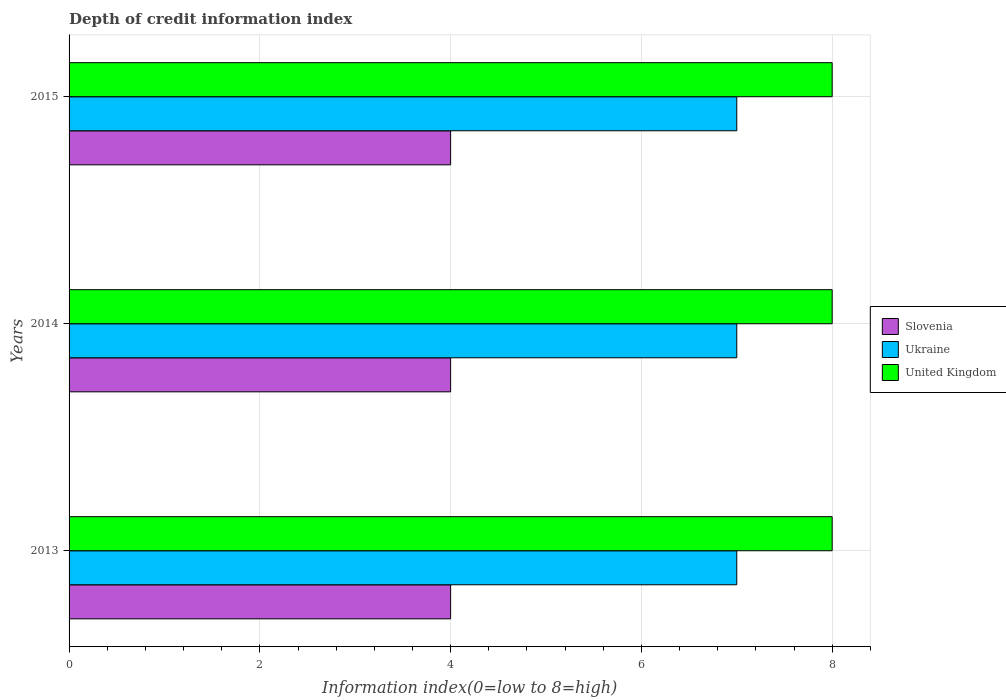How many groups of bars are there?
Provide a succinct answer. 3. Are the number of bars on each tick of the Y-axis equal?
Your answer should be compact. Yes. How many bars are there on the 2nd tick from the bottom?
Offer a terse response. 3. What is the label of the 2nd group of bars from the top?
Your response must be concise. 2014. In how many cases, is the number of bars for a given year not equal to the number of legend labels?
Your response must be concise. 0. What is the information index in Ukraine in 2014?
Your response must be concise. 7. Across all years, what is the maximum information index in Slovenia?
Your answer should be very brief. 4. Across all years, what is the minimum information index in Slovenia?
Provide a succinct answer. 4. What is the total information index in Ukraine in the graph?
Make the answer very short. 21. What is the difference between the information index in United Kingdom in 2013 and that in 2014?
Offer a very short reply. 0. What is the difference between the information index in United Kingdom in 2014 and the information index in Slovenia in 2015?
Keep it short and to the point. 4. What is the average information index in Slovenia per year?
Make the answer very short. 4. In the year 2015, what is the difference between the information index in Ukraine and information index in Slovenia?
Offer a very short reply. 3. What is the ratio of the information index in Slovenia in 2013 to that in 2014?
Your answer should be very brief. 1. Is the difference between the information index in Ukraine in 2013 and 2014 greater than the difference between the information index in Slovenia in 2013 and 2014?
Offer a terse response. No. What is the difference between the highest and the second highest information index in Slovenia?
Your response must be concise. 0. What is the difference between the highest and the lowest information index in United Kingdom?
Your response must be concise. 0. In how many years, is the information index in Ukraine greater than the average information index in Ukraine taken over all years?
Offer a terse response. 0. What does the 2nd bar from the top in 2013 represents?
Provide a succinct answer. Ukraine. What does the 1st bar from the bottom in 2013 represents?
Provide a succinct answer. Slovenia. How many bars are there?
Provide a short and direct response. 9. How many years are there in the graph?
Provide a succinct answer. 3. Are the values on the major ticks of X-axis written in scientific E-notation?
Offer a terse response. No. Where does the legend appear in the graph?
Offer a terse response. Center right. What is the title of the graph?
Your response must be concise. Depth of credit information index. What is the label or title of the X-axis?
Your answer should be very brief. Information index(0=low to 8=high). What is the label or title of the Y-axis?
Offer a very short reply. Years. What is the Information index(0=low to 8=high) in Slovenia in 2013?
Keep it short and to the point. 4. What is the Information index(0=low to 8=high) of Ukraine in 2013?
Provide a succinct answer. 7. What is the Information index(0=low to 8=high) in Slovenia in 2015?
Give a very brief answer. 4. What is the Information index(0=low to 8=high) of United Kingdom in 2015?
Give a very brief answer. 8. Across all years, what is the maximum Information index(0=low to 8=high) of Slovenia?
Offer a very short reply. 4. Across all years, what is the minimum Information index(0=low to 8=high) of Slovenia?
Make the answer very short. 4. Across all years, what is the minimum Information index(0=low to 8=high) of United Kingdom?
Keep it short and to the point. 8. What is the total Information index(0=low to 8=high) in Slovenia in the graph?
Your response must be concise. 12. What is the total Information index(0=low to 8=high) in United Kingdom in the graph?
Make the answer very short. 24. What is the difference between the Information index(0=low to 8=high) of Slovenia in 2013 and that in 2014?
Offer a very short reply. 0. What is the difference between the Information index(0=low to 8=high) of Ukraine in 2013 and that in 2014?
Offer a very short reply. 0. What is the difference between the Information index(0=low to 8=high) of Ukraine in 2013 and that in 2015?
Ensure brevity in your answer.  0. What is the difference between the Information index(0=low to 8=high) in Slovenia in 2014 and that in 2015?
Your response must be concise. 0. What is the difference between the Information index(0=low to 8=high) in Ukraine in 2014 and that in 2015?
Your response must be concise. 0. What is the difference between the Information index(0=low to 8=high) in United Kingdom in 2014 and that in 2015?
Offer a very short reply. 0. What is the difference between the Information index(0=low to 8=high) in Slovenia in 2013 and the Information index(0=low to 8=high) in Ukraine in 2015?
Your answer should be very brief. -3. What is the difference between the Information index(0=low to 8=high) of Ukraine in 2013 and the Information index(0=low to 8=high) of United Kingdom in 2015?
Offer a very short reply. -1. What is the difference between the Information index(0=low to 8=high) in Slovenia in 2014 and the Information index(0=low to 8=high) in Ukraine in 2015?
Provide a succinct answer. -3. What is the average Information index(0=low to 8=high) of Ukraine per year?
Your response must be concise. 7. In the year 2013, what is the difference between the Information index(0=low to 8=high) in Slovenia and Information index(0=low to 8=high) in Ukraine?
Provide a short and direct response. -3. In the year 2013, what is the difference between the Information index(0=low to 8=high) of Slovenia and Information index(0=low to 8=high) of United Kingdom?
Give a very brief answer. -4. In the year 2013, what is the difference between the Information index(0=low to 8=high) of Ukraine and Information index(0=low to 8=high) of United Kingdom?
Provide a succinct answer. -1. In the year 2014, what is the difference between the Information index(0=low to 8=high) in Slovenia and Information index(0=low to 8=high) in Ukraine?
Give a very brief answer. -3. In the year 2014, what is the difference between the Information index(0=low to 8=high) of Slovenia and Information index(0=low to 8=high) of United Kingdom?
Provide a succinct answer. -4. In the year 2014, what is the difference between the Information index(0=low to 8=high) in Ukraine and Information index(0=low to 8=high) in United Kingdom?
Ensure brevity in your answer.  -1. In the year 2015, what is the difference between the Information index(0=low to 8=high) in Slovenia and Information index(0=low to 8=high) in Ukraine?
Offer a terse response. -3. What is the ratio of the Information index(0=low to 8=high) in Slovenia in 2013 to that in 2015?
Keep it short and to the point. 1. What is the ratio of the Information index(0=low to 8=high) of Ukraine in 2014 to that in 2015?
Offer a terse response. 1. What is the ratio of the Information index(0=low to 8=high) in United Kingdom in 2014 to that in 2015?
Offer a very short reply. 1. What is the difference between the highest and the second highest Information index(0=low to 8=high) of Slovenia?
Keep it short and to the point. 0. What is the difference between the highest and the second highest Information index(0=low to 8=high) in United Kingdom?
Your answer should be compact. 0. What is the difference between the highest and the lowest Information index(0=low to 8=high) in Slovenia?
Provide a succinct answer. 0. What is the difference between the highest and the lowest Information index(0=low to 8=high) of Ukraine?
Your response must be concise. 0. 